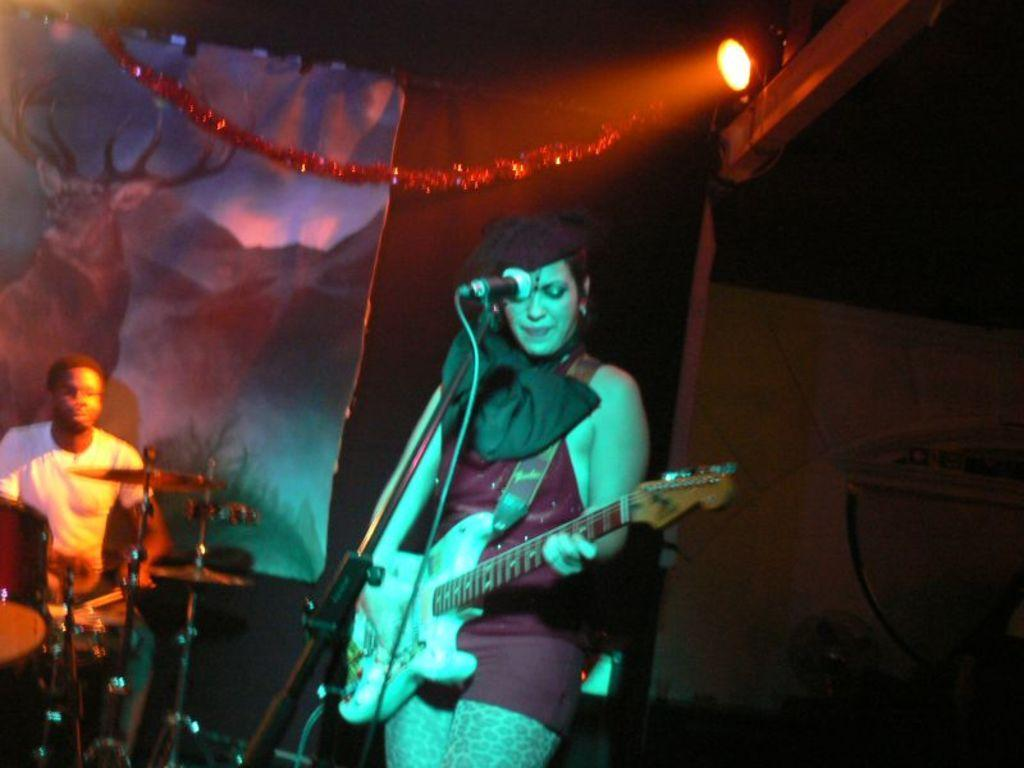Who is the main subject in the image? There is a woman in the image. Where is the woman located in the image? The woman is standing in the middle of the image. What is the woman holding in the image? The woman is holding a guitar. What is the woman wearing in the image? The woman is wearing a red color dress at the top. Who else is present in the image? There is a man in the image. Where is the man located in the image? The man is on the left side of the image. What is the man doing in the image? The man is beating the drums. What can be seen on the right side of the image? There is a light in the right side of the image. How many toads are present in the image? There are no toads present in the image. What type of line is being used by the woman to play the guitar? The woman is not using a line to play the guitar; she is holding the guitar with her hands. 